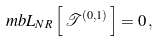Convert formula to latex. <formula><loc_0><loc_0><loc_500><loc_500>\ m b { L _ { N R } } \left [ \, \mathcal { T } ^ { ( 0 , 1 ) } \, \right ] = 0 \, ,</formula> 